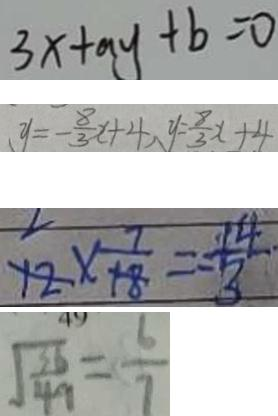Convert formula to latex. <formula><loc_0><loc_0><loc_500><loc_500>3 x + a y + b = 0 
 y = - \frac { 8 } { 3 } x + 4 , y = \frac { 8 } { 3 } x + 4 
 1 2 \times \frac { 7 } { 1 8 } = \frac { 1 4 } { 3 } 
 \sqrt { \frac { 3 6 } { 4 9 } } = \frac { 6 } { 7 }</formula> 